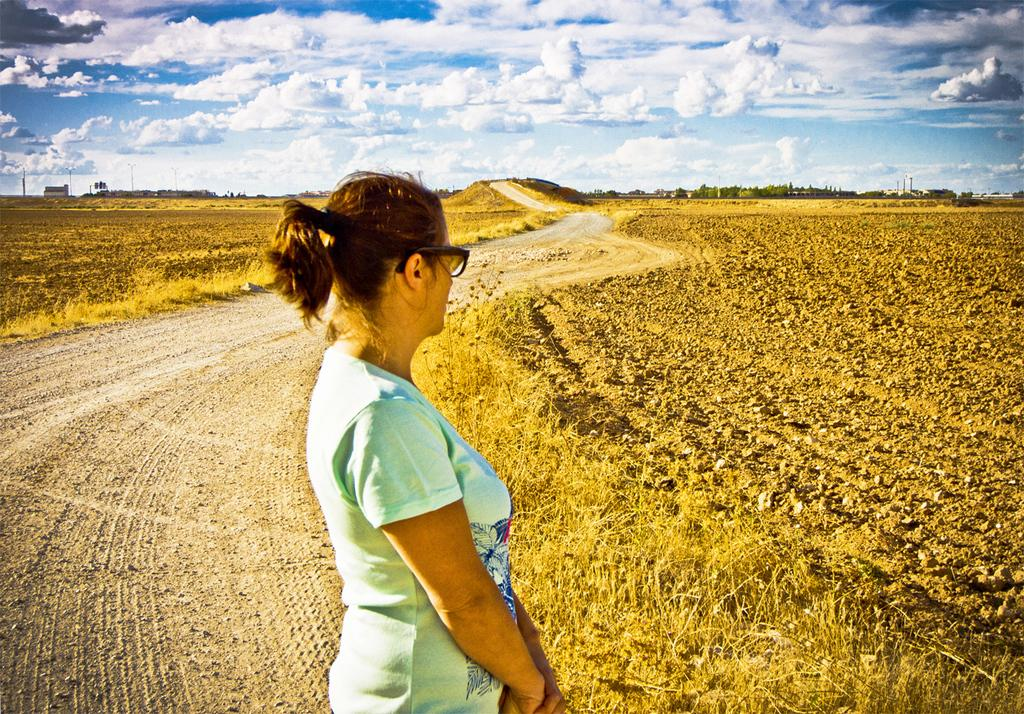What is the main subject of the image? There is a lady standing in the image. What can be seen in the background of the image? There is farming land on both sides of the image. What type of vegetation is present in the image? There are many trees in the image. What type of road is visible in the image? There is a mud road in the image. What type of prison can be seen in the image? There is no prison present in the image. Can you tell me how many baseball bats are visible in the image? There are no baseball bats present in the image. 